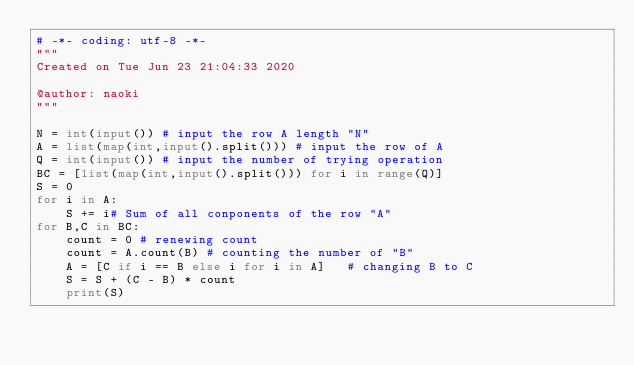Convert code to text. <code><loc_0><loc_0><loc_500><loc_500><_Python_># -*- coding: utf-8 -*-
"""
Created on Tue Jun 23 21:04:33 2020

@author: naoki
"""

N = int(input()) # input the row A length "N" 
A = list(map(int,input().split())) # input the row of A 
Q = int(input()) # input the number of trying operation 
BC = [list(map(int,input().split())) for i in range(Q)]
S = 0 
for i in A:
    S += i# Sum of all conponents of the row "A"
for B,C in BC:
    count = 0 # renewing count 
    count = A.count(B) # counting the number of "B"
    A = [C if i == B else i for i in A]   # changing B to C  
    S = S + (C - B) * count 
    print(S)

</code> 